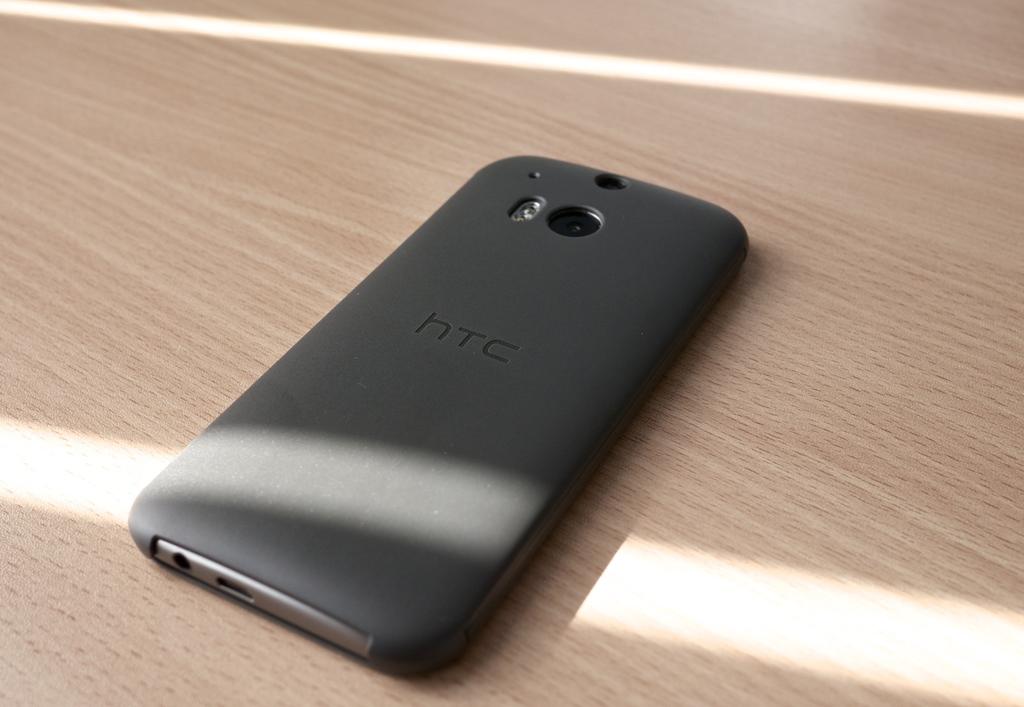What brand manufactured this cell phone?
Your response must be concise. Htc. Is this an htc phone?
Your answer should be compact. Yes. 